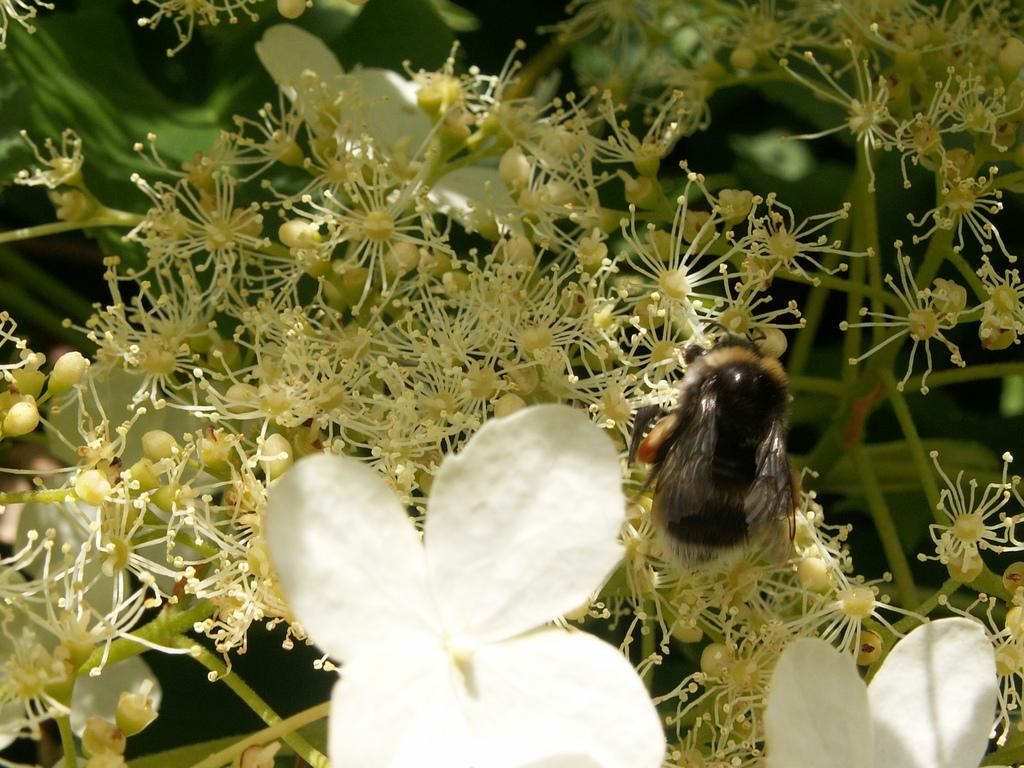What is the main subject of the image? There is a bunch of flowers in the image. Can you describe the flowers in more detail? There are some buds in the image, indicating that the flowers are at different stages of blooming. Is there anything else present on the flowers in the image? Yes, there is an insect on the flowers in the image. What type of nut can be seen hanging from the tree in the image? There is no tree or nut present in the image; it features a bunch of flowers with an insect on them. Which direction is the quilt facing in the image? There is no quilt present in the image. 